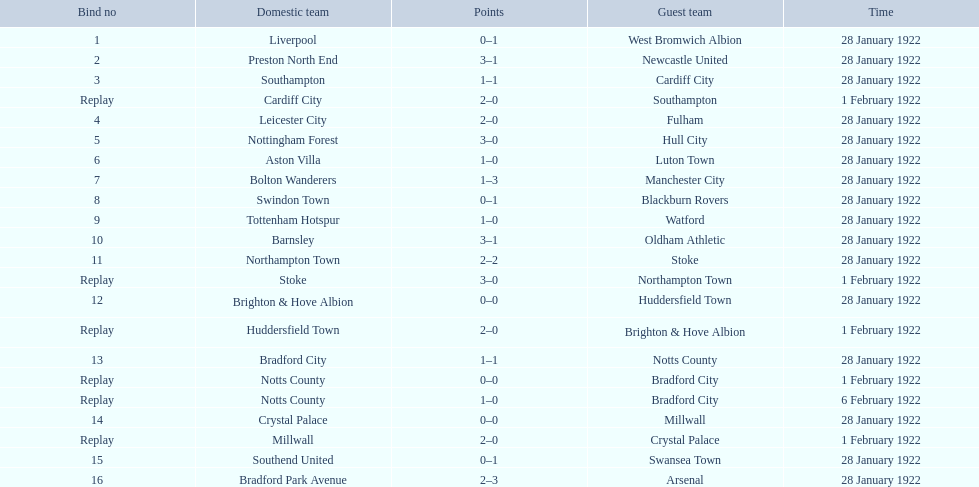What are all of the home teams? Liverpool, Preston North End, Southampton, Cardiff City, Leicester City, Nottingham Forest, Aston Villa, Bolton Wanderers, Swindon Town, Tottenham Hotspur, Barnsley, Northampton Town, Stoke, Brighton & Hove Albion, Huddersfield Town, Bradford City, Notts County, Notts County, Crystal Palace, Millwall, Southend United, Bradford Park Avenue. What were the scores? 0–1, 3–1, 1–1, 2–0, 2–0, 3–0, 1–0, 1–3, 0–1, 1–0, 3–1, 2–2, 3–0, 0–0, 2–0, 1–1, 0–0, 1–0, 0–0, 2–0, 0–1, 2–3. On which dates did they play? 28 January 1922, 28 January 1922, 28 January 1922, 1 February 1922, 28 January 1922, 28 January 1922, 28 January 1922, 28 January 1922, 28 January 1922, 28 January 1922, 28 January 1922, 28 January 1922, 1 February 1922, 28 January 1922, 1 February 1922, 28 January 1922, 1 February 1922, 6 February 1922, 28 January 1922, 1 February 1922, 28 January 1922, 28 January 1922. Which teams played on 28 january 1922? Liverpool, Preston North End, Southampton, Leicester City, Nottingham Forest, Aston Villa, Bolton Wanderers, Swindon Town, Tottenham Hotspur, Barnsley, Northampton Town, Brighton & Hove Albion, Bradford City, Crystal Palace, Southend United, Bradford Park Avenue. Of those, which scored the same as aston villa? Tottenham Hotspur. 